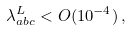<formula> <loc_0><loc_0><loc_500><loc_500>\lambda ^ { L } _ { a b c } < O ( 1 0 ^ { - 4 } ) \, ,</formula> 